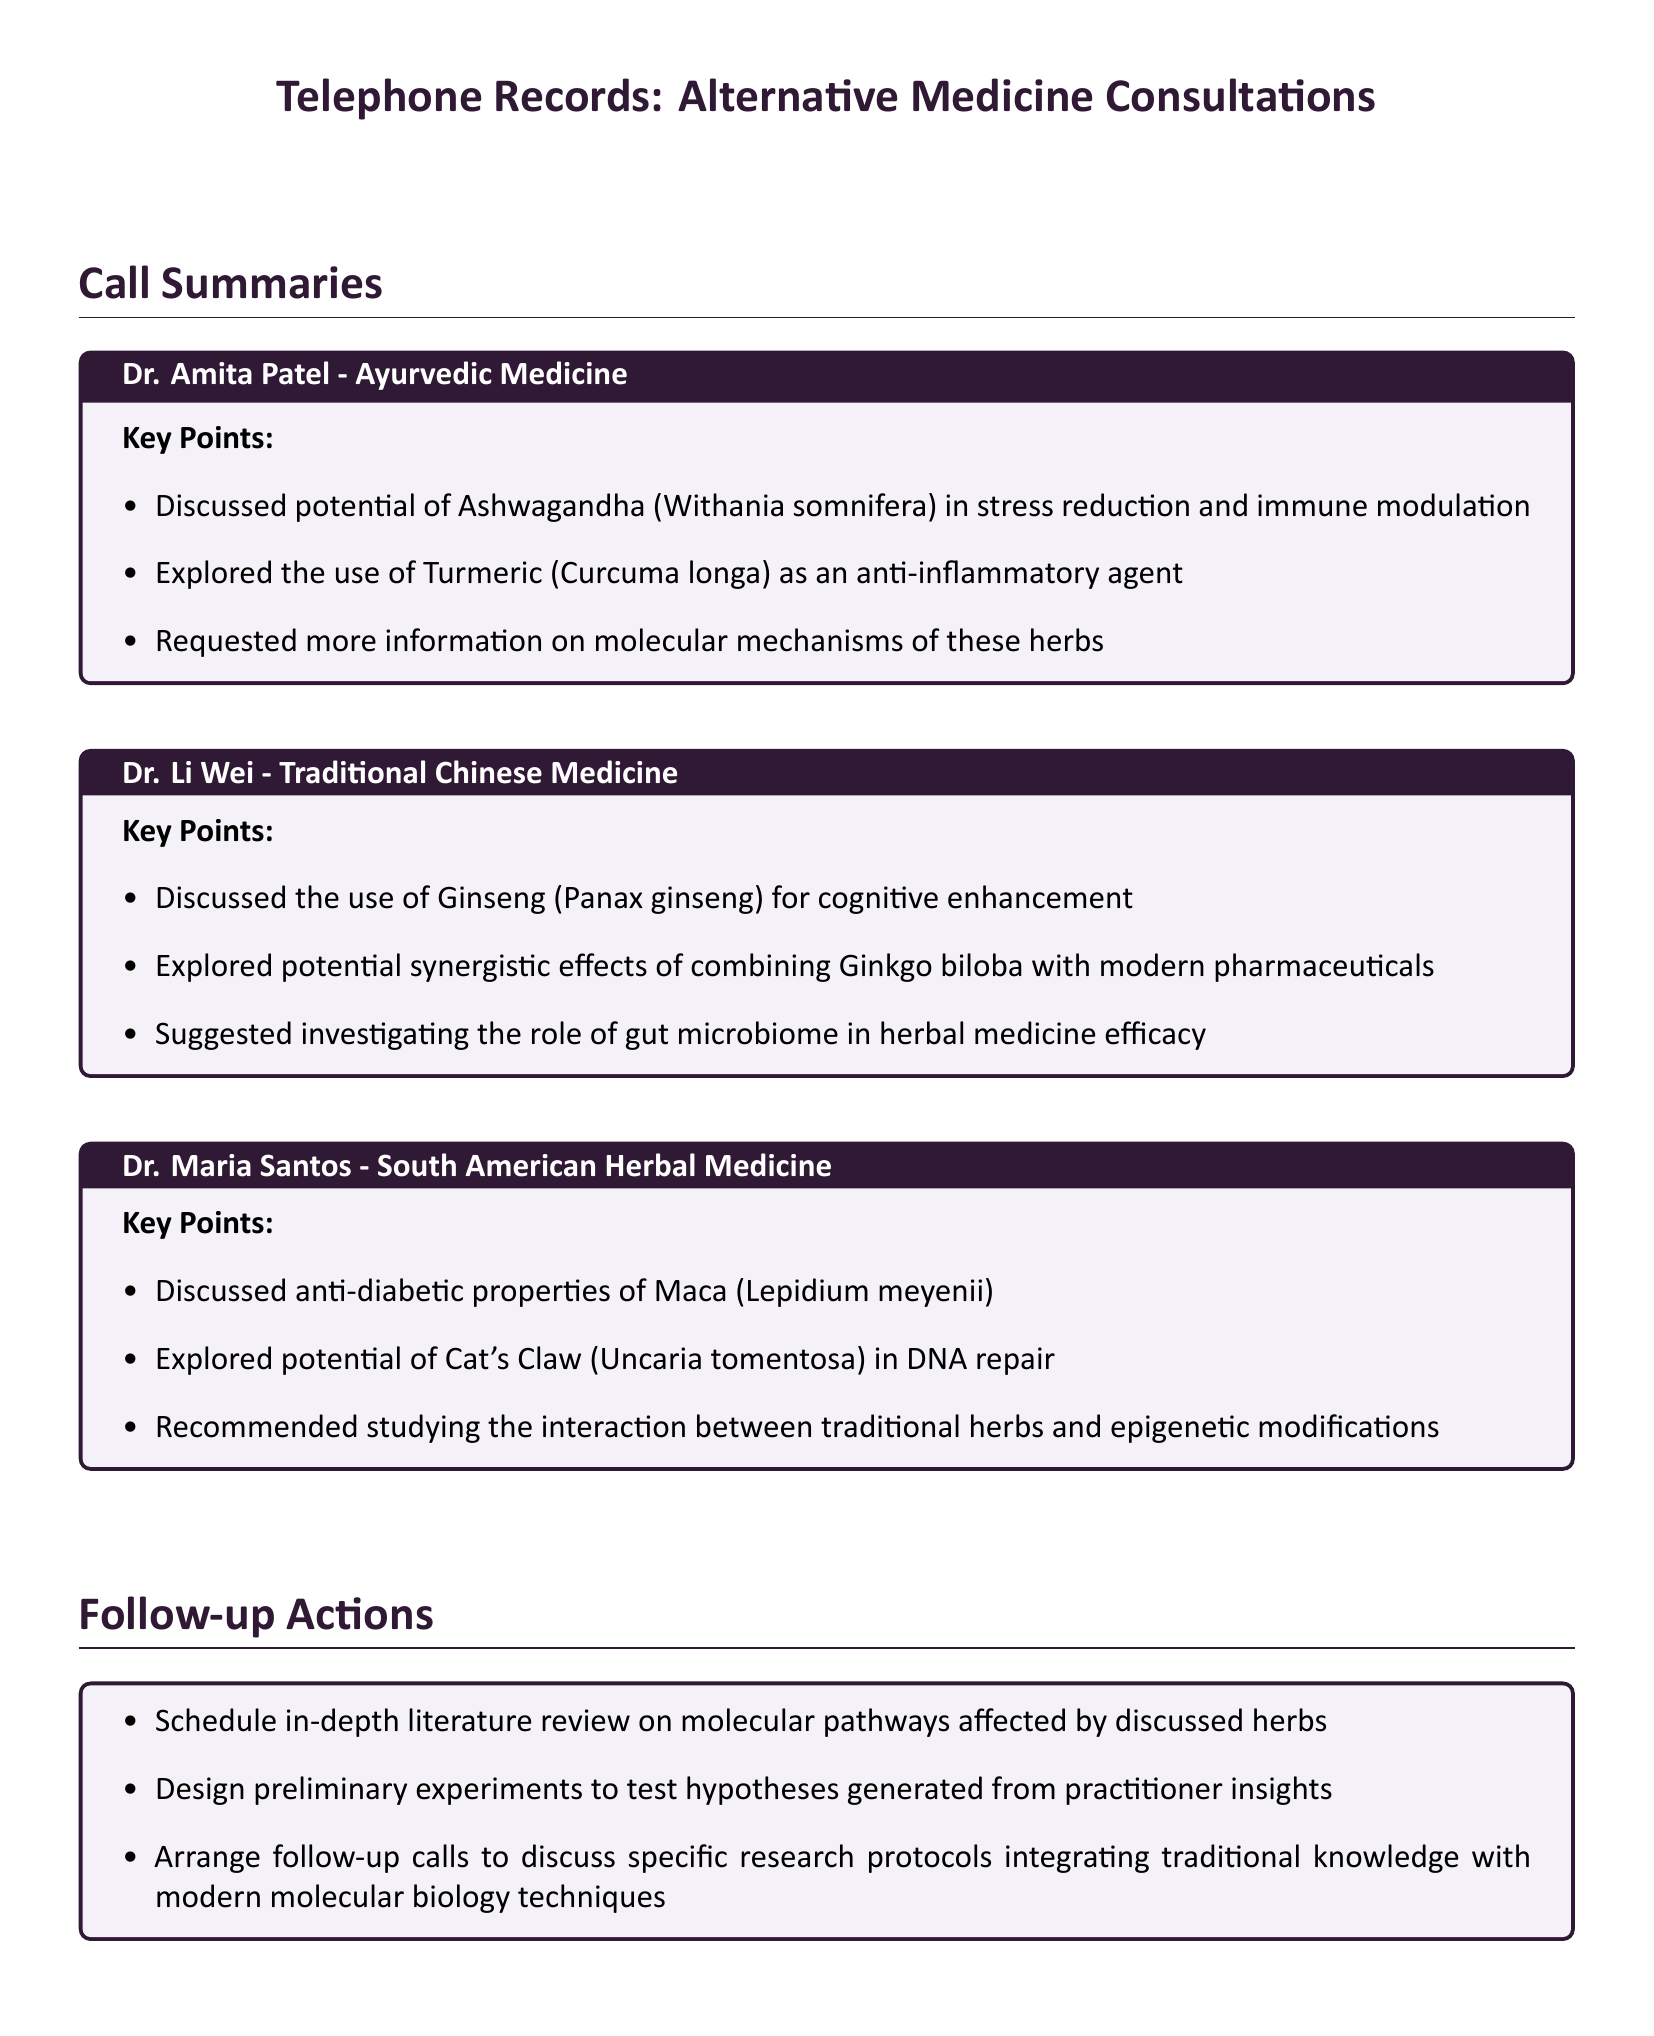What herb was discussed for stress reduction? The herb discussed for stress reduction is Ashwagandha (Withania somnifera), as mentioned in Dr. Amita Patel's summary.
Answer: Ashwagandha What potential benefit of Turmeric was mentioned? Turmeric (Curcuma longa) was explored as an anti-inflammatory agent according to Dr. Amita Patel's call summary.
Answer: Anti-inflammatory Which practitioner discussed the use of Ginseng? Dr. Li Wei discussed the use of Ginseng (Panax ginseng) for cognitive enhancement in the calls.
Answer: Dr. Li Wei What was suggested to investigate regarding herbal medicine efficacy? The role of gut microbiome in herbal medicine efficacy was suggested by Dr. Li Wei during the consultation.
Answer: Gut microbiome What are the anti-diabetic properties of which herb were discussed? The anti-diabetic properties of Maca (Lepidium meyenii) were discussed by Dr. Maria Santos.
Answer: Maca What action is suggested to follow up on herbal studies? Scheduling an in-depth literature review on molecular pathways affected by discussed herbs is a suggested follow-up action.
Answer: Literature review What is one recommended study area to explore interaction with traditional herbs? The interaction between traditional herbs and epigenetic modifications was recommended for study in Dr. Maria Santos's summary.
Answer: Epigenetic modifications 